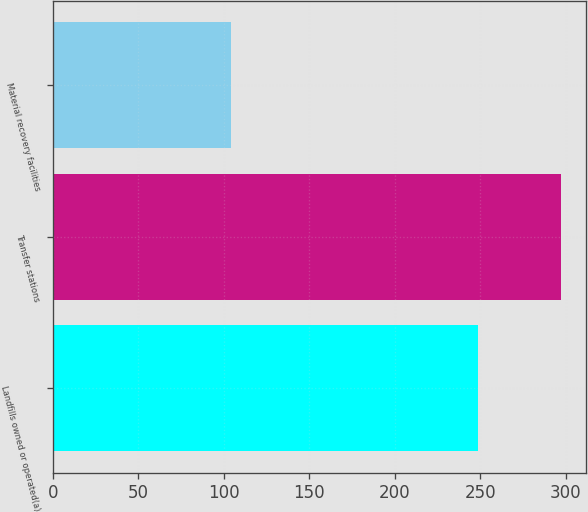<chart> <loc_0><loc_0><loc_500><loc_500><bar_chart><fcel>Landfills owned or operated(a)<fcel>Transfer stations<fcel>Material recovery facilities<nl><fcel>249<fcel>297<fcel>104<nl></chart> 